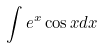Convert formula to latex. <formula><loc_0><loc_0><loc_500><loc_500>\int e ^ { x } \cos x d x</formula> 